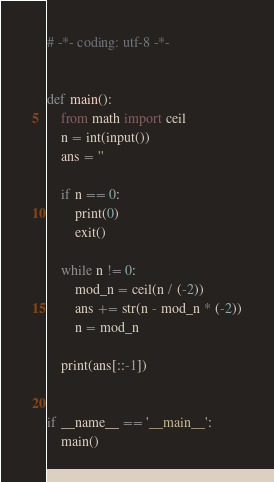Convert code to text. <code><loc_0><loc_0><loc_500><loc_500><_Python_># -*- coding: utf-8 -*-


def main():
    from math import ceil
    n = int(input())
    ans = ''

    if n == 0:
        print(0)
        exit()

    while n != 0:
        mod_n = ceil(n / (-2))
        ans += str(n - mod_n * (-2))
        n = mod_n

    print(ans[::-1])


if __name__ == '__main__':
    main()
</code> 